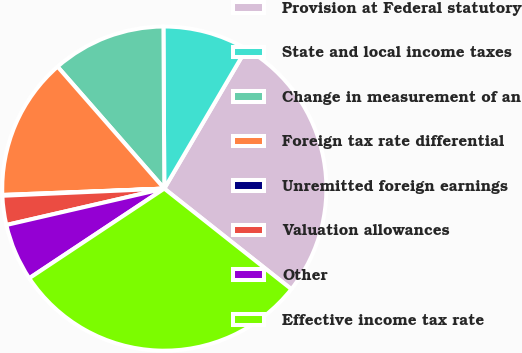Convert chart to OTSL. <chart><loc_0><loc_0><loc_500><loc_500><pie_chart><fcel>Provision at Federal statutory<fcel>State and local income taxes<fcel>Change in measurement of an<fcel>Foreign tax rate differential<fcel>Unremitted foreign earnings<fcel>Valuation allowances<fcel>Other<fcel>Effective income tax rate<nl><fcel>27.2%<fcel>8.54%<fcel>11.36%<fcel>14.18%<fcel>0.08%<fcel>2.9%<fcel>5.72%<fcel>30.02%<nl></chart> 